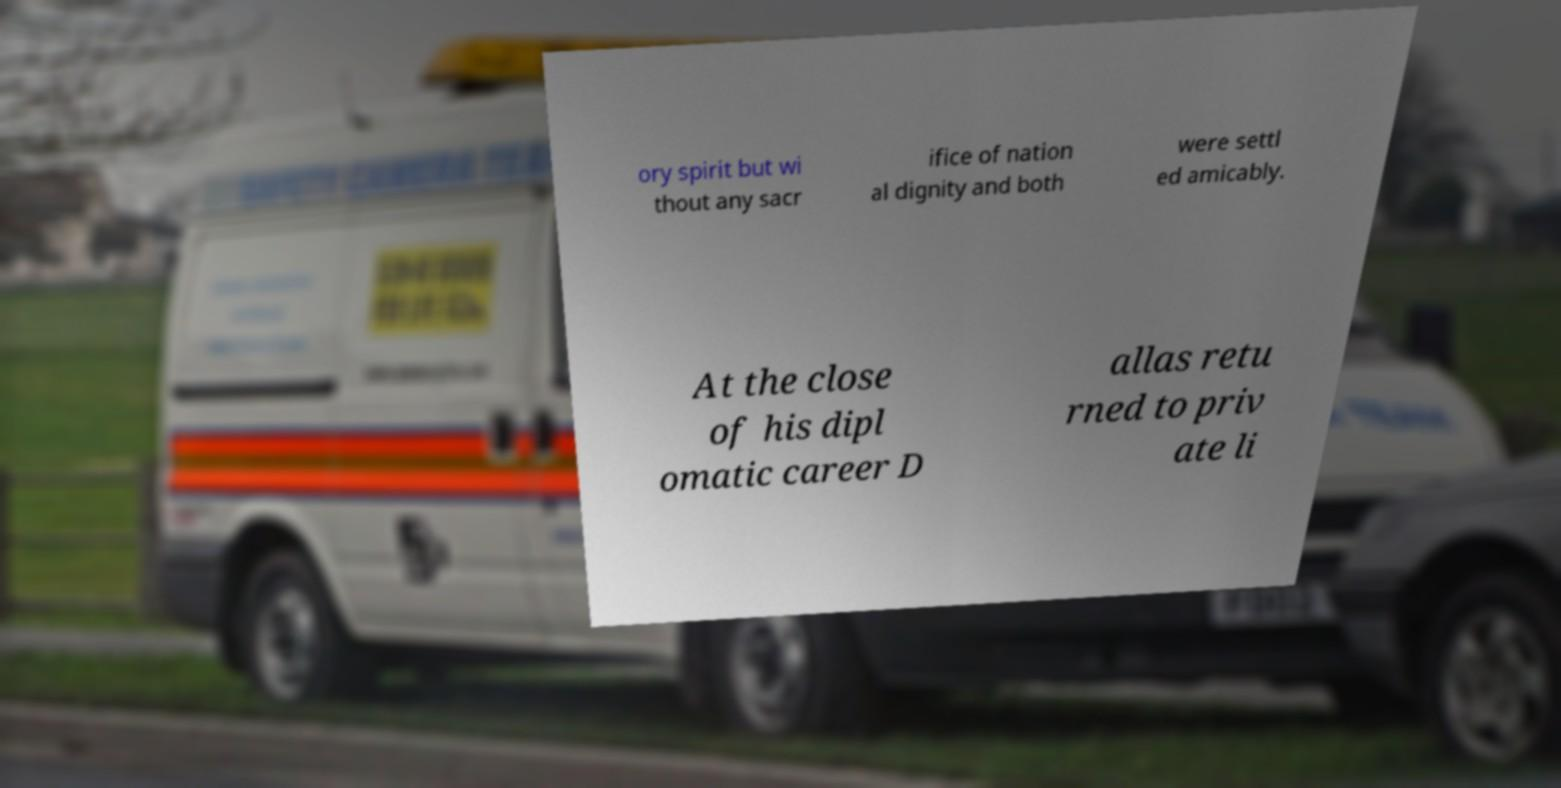What messages or text are displayed in this image? I need them in a readable, typed format. ory spirit but wi thout any sacr ifice of nation al dignity and both were settl ed amicably. At the close of his dipl omatic career D allas retu rned to priv ate li 